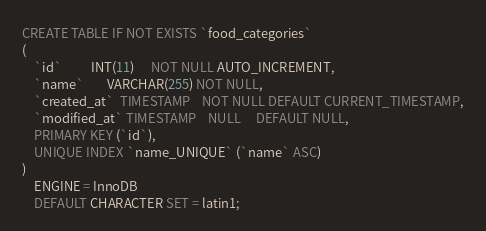Convert code to text. <code><loc_0><loc_0><loc_500><loc_500><_SQL_>CREATE TABLE IF NOT EXISTS `food_categories`
(
    `id`          INT(11)      NOT NULL AUTO_INCREMENT,
    `name`        VARCHAR(255) NOT NULL,
    `created_at`  TIMESTAMP    NOT NULL DEFAULT CURRENT_TIMESTAMP,
    `modified_at` TIMESTAMP    NULL     DEFAULT NULL,
    PRIMARY KEY (`id`),
    UNIQUE INDEX `name_UNIQUE` (`name` ASC)
)
    ENGINE = InnoDB
    DEFAULT CHARACTER SET = latin1;</code> 